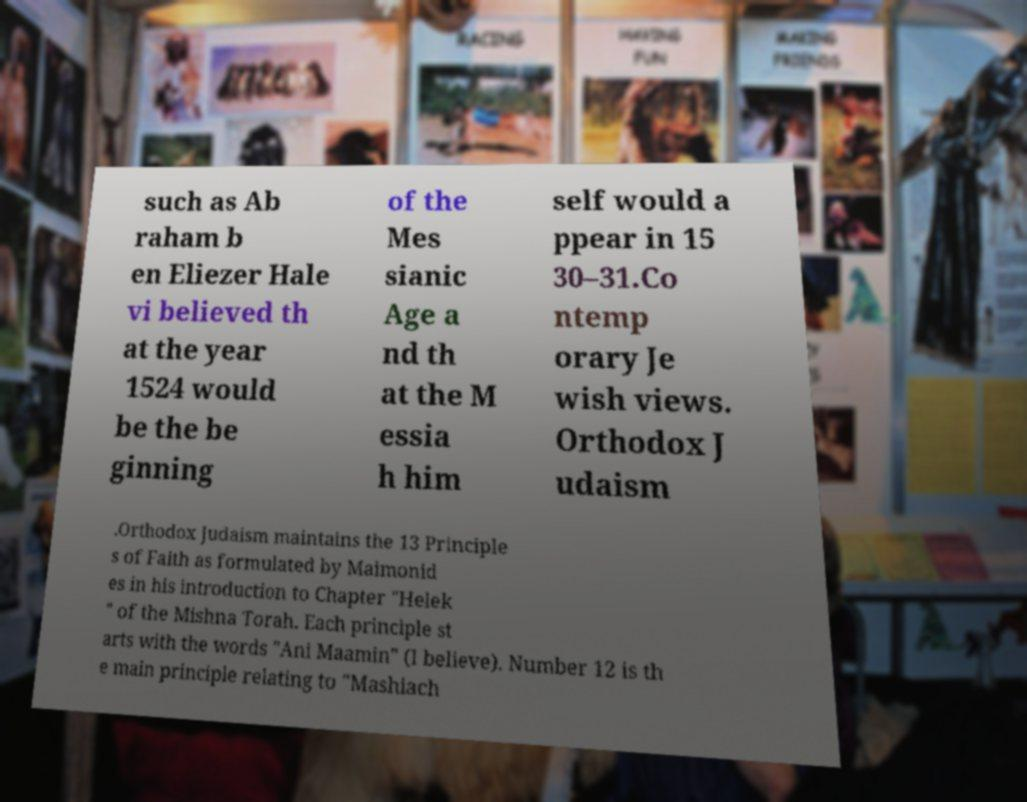Please read and relay the text visible in this image. What does it say? such as Ab raham b en Eliezer Hale vi believed th at the year 1524 would be the be ginning of the Mes sianic Age a nd th at the M essia h him self would a ppear in 15 30–31.Co ntemp orary Je wish views. Orthodox J udaism .Orthodox Judaism maintains the 13 Principle s of Faith as formulated by Maimonid es in his introduction to Chapter "Helek " of the Mishna Torah. Each principle st arts with the words "Ani Maamin" (I believe). Number 12 is th e main principle relating to "Mashiach 